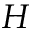Convert formula to latex. <formula><loc_0><loc_0><loc_500><loc_500>H</formula> 